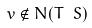Convert formula to latex. <formula><loc_0><loc_0><loc_500><loc_500>v \notin N ( T \ S )</formula> 